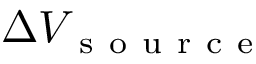Convert formula to latex. <formula><loc_0><loc_0><loc_500><loc_500>\Delta V _ { s o u r c e }</formula> 